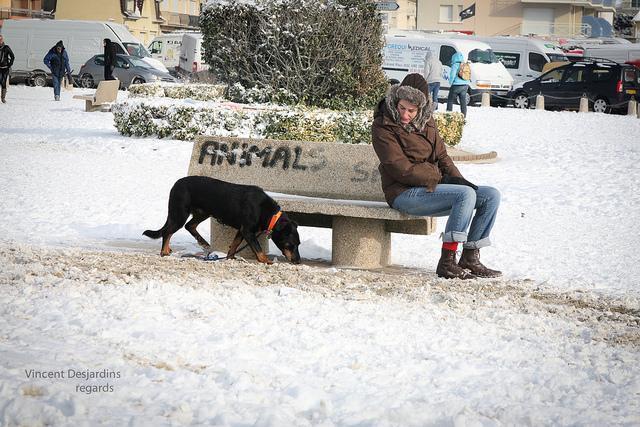What physical danger could she face if she was stuck in the cold with no winter apparel?
Make your selection from the four choices given to correctly answer the question.
Options: Frostbite, sunburn, nothing, chicken pox. Frostbite. 